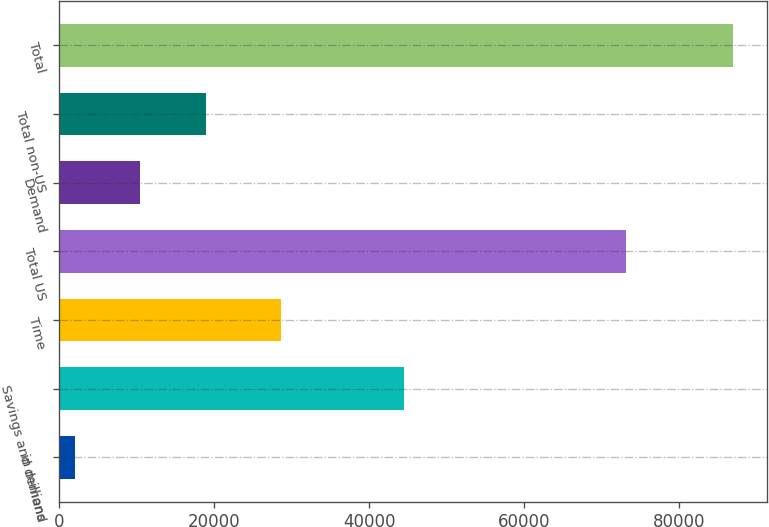Convert chart to OTSL. <chart><loc_0><loc_0><loc_500><loc_500><bar_chart><fcel>in millions<fcel>Savings and demand<fcel>Time<fcel>Total US<fcel>Demand<fcel>Total non-US<fcel>Total<nl><fcel>2015<fcel>44486<fcel>28577<fcel>73063<fcel>10508.3<fcel>19001.6<fcel>86948<nl></chart> 